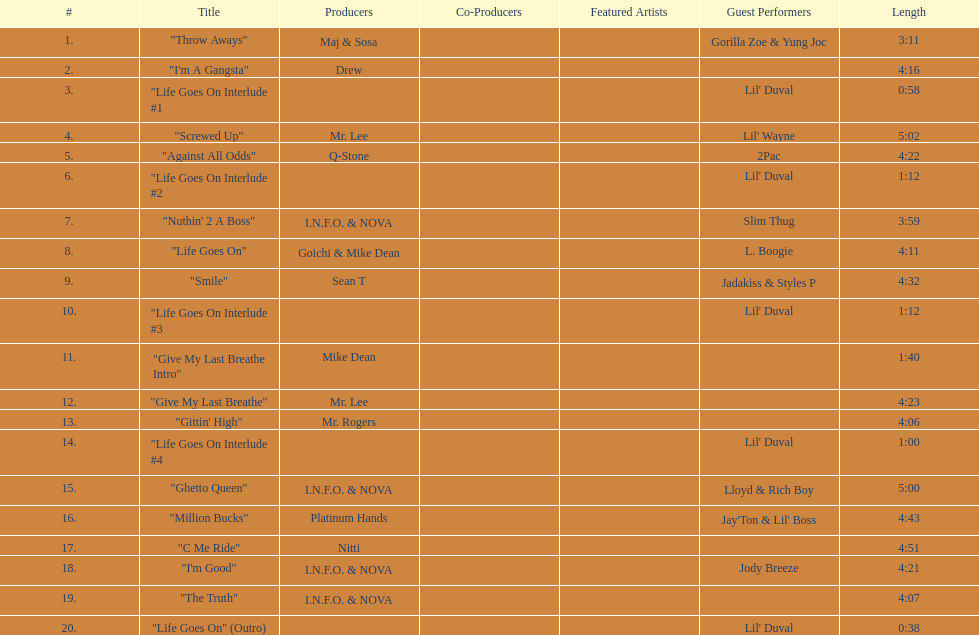What is the number of tracks featuring 2pac? 1. Parse the table in full. {'header': ['#', 'Title', 'Producers', 'Co-Producers', 'Featured Artists', 'Guest Performers', 'Length'], 'rows': [['1.', '"Throw Aways"', 'Maj & Sosa', '', '', 'Gorilla Zoe & Yung Joc', '3:11'], ['2.', '"I\'m A Gangsta"', 'Drew', '', '', '', '4:16'], ['3.', '"Life Goes On Interlude #1', '', '', '', "Lil' Duval", '0:58'], ['4.', '"Screwed Up"', 'Mr. Lee', '', '', "Lil' Wayne", '5:02'], ['5.', '"Against All Odds"', 'Q-Stone', '', '', '2Pac', '4:22'], ['6.', '"Life Goes On Interlude #2', '', '', '', "Lil' Duval", '1:12'], ['7.', '"Nuthin\' 2 A Boss"', 'I.N.F.O. & NOVA', '', '', 'Slim Thug', '3:59'], ['8.', '"Life Goes On"', 'Goichi & Mike Dean', '', '', 'L. Boogie', '4:11'], ['9.', '"Smile"', 'Sean T', '', '', 'Jadakiss & Styles P', '4:32'], ['10.', '"Life Goes On Interlude #3', '', '', '', "Lil' Duval", '1:12'], ['11.', '"Give My Last Breathe Intro"', 'Mike Dean', '', '', '', '1:40'], ['12.', '"Give My Last Breathe"', 'Mr. Lee', '', '', '', '4:23'], ['13.', '"Gittin\' High"', 'Mr. Rogers', '', '', '', '4:06'], ['14.', '"Life Goes On Interlude #4', '', '', '', "Lil' Duval", '1:00'], ['15.', '"Ghetto Queen"', 'I.N.F.O. & NOVA', '', '', 'Lloyd & Rich Boy', '5:00'], ['16.', '"Million Bucks"', 'Platinum Hands', '', '', "Jay'Ton & Lil' Boss", '4:43'], ['17.', '"C Me Ride"', 'Nitti', '', '', '', '4:51'], ['18.', '"I\'m Good"', 'I.N.F.O. & NOVA', '', '', 'Jody Breeze', '4:21'], ['19.', '"The Truth"', 'I.N.F.O. & NOVA', '', '', '', '4:07'], ['20.', '"Life Goes On" (Outro)', '', '', '', "Lil' Duval", '0:38']]} 